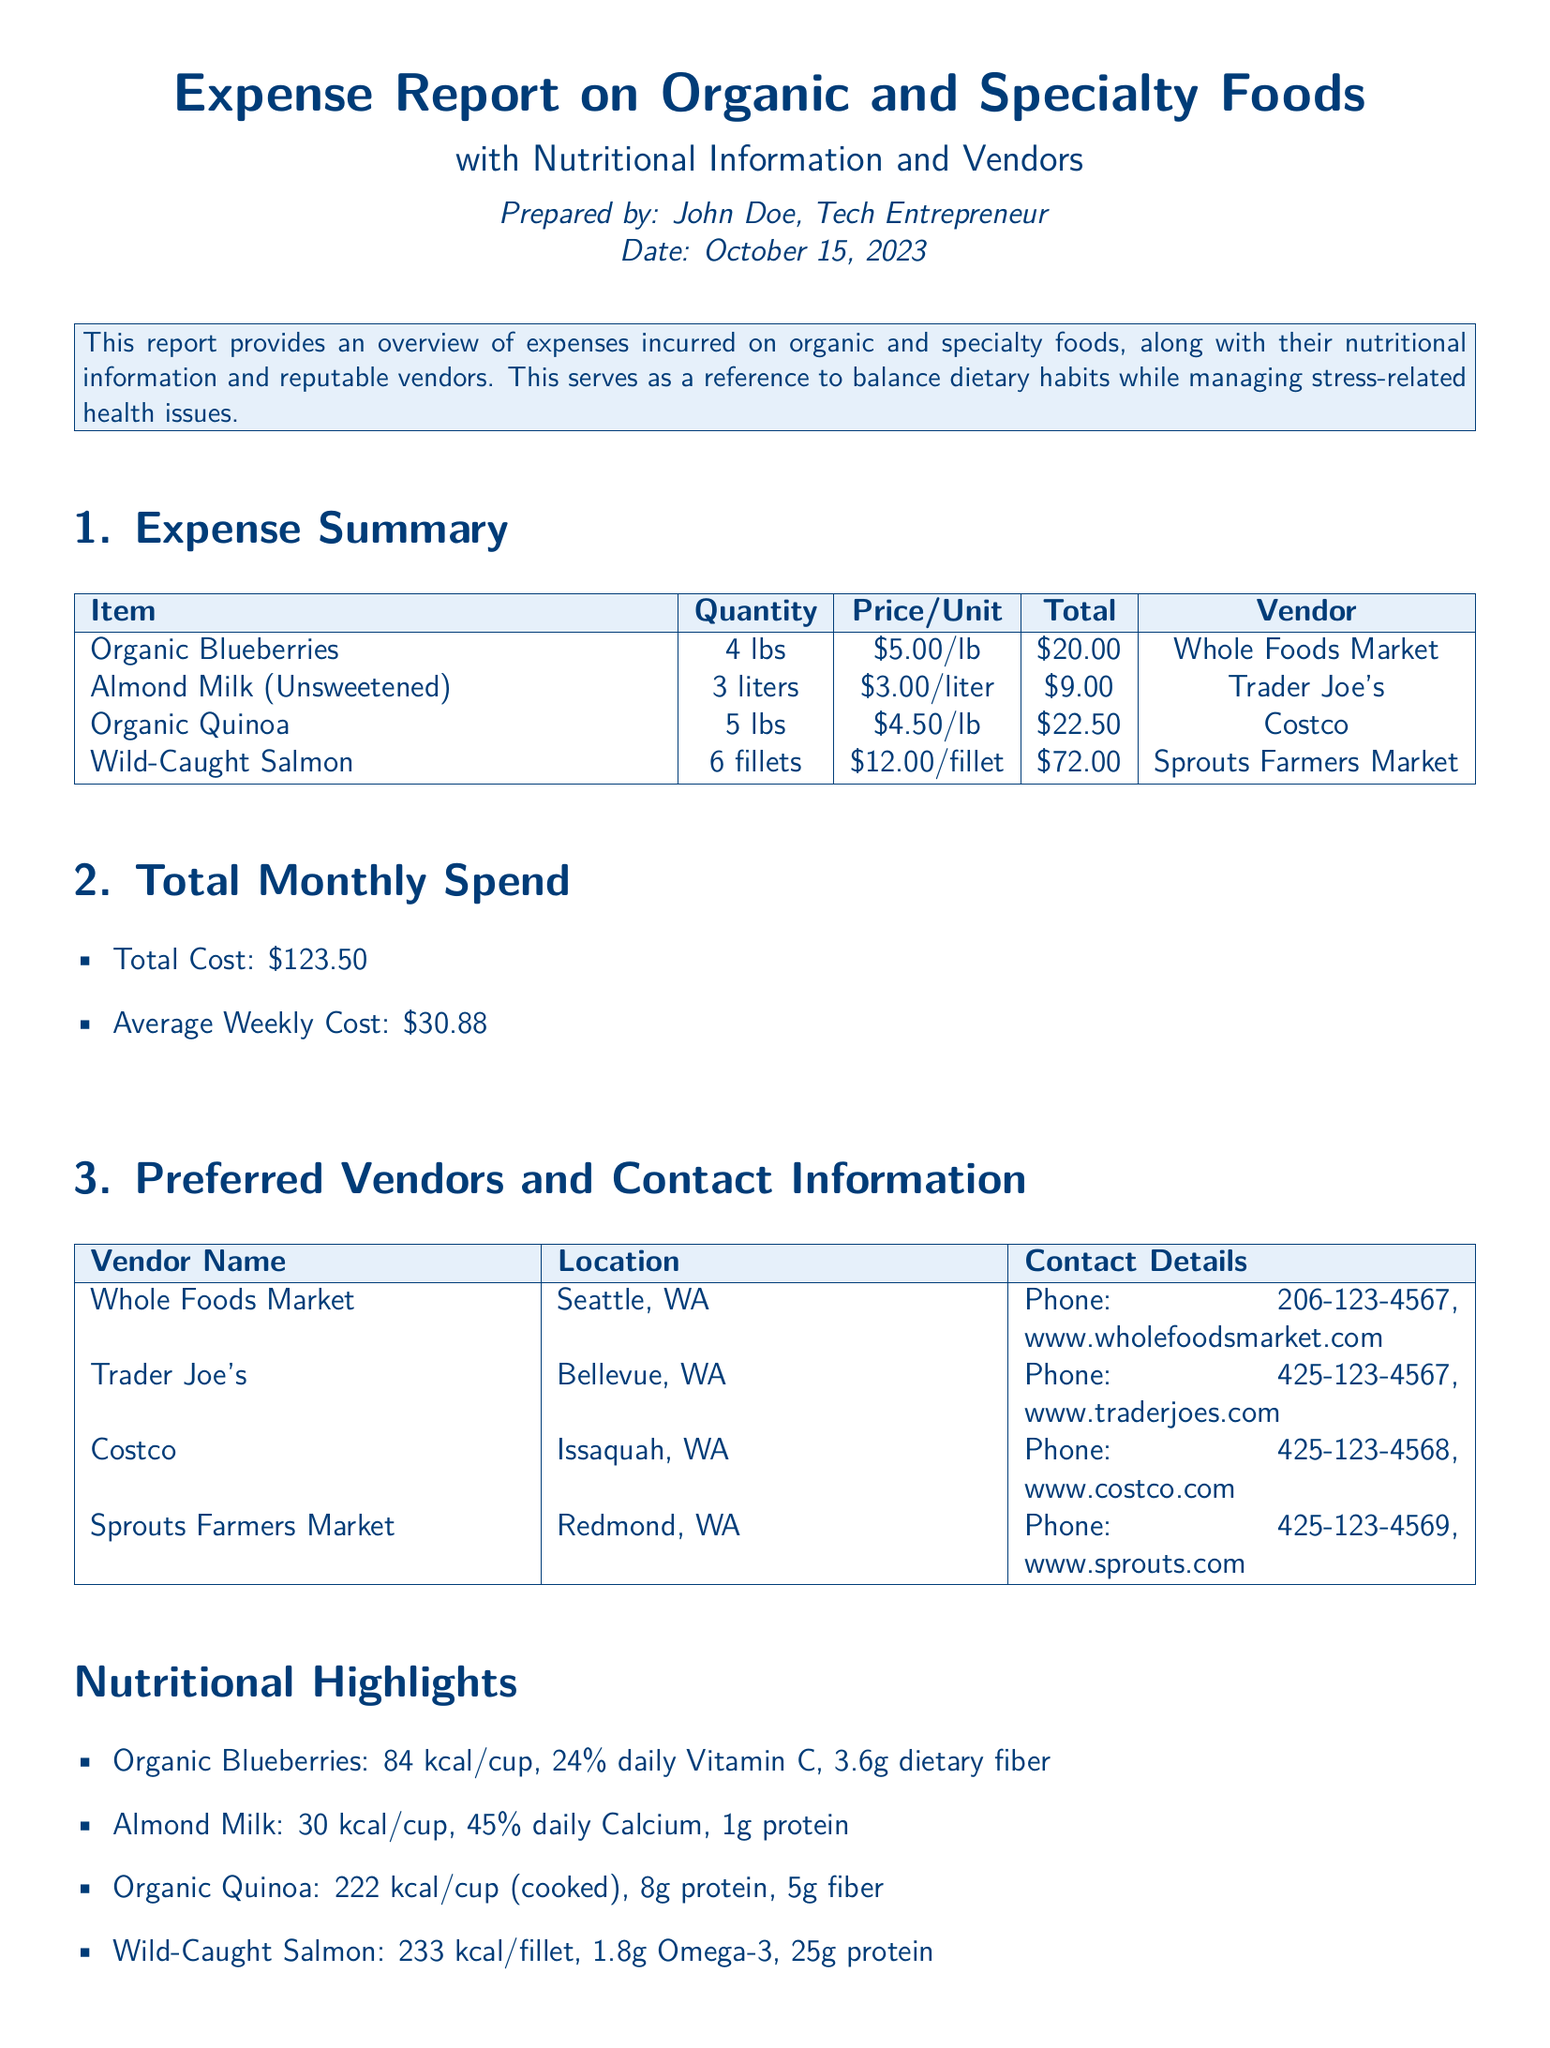What is the total cost of expenses? The total cost is shown in the Total Monthly Spend section as $123.50.
Answer: $123.50 How many pounds of organic blueberries were purchased? The Quantity column in the Expense Summary shows that 4 lbs of organic blueberries were purchased.
Answer: 4 lbs Who is the vendor for wild-caught salmon? The Expense Summary lists Sprouts Farmers Market as the vendor for wild-caught salmon.
Answer: Sprouts Farmers Market What is the average weekly cost of the expenses? The average weekly cost is calculated in the Total Monthly Spend section as $30.88.
Answer: $30.88 How many grams of protein are in one fillet of wild-caught salmon? The Nutritional Highlights indicate that one fillet contains 25g of protein.
Answer: 25g Which vendor is located in Bellevue, WA? The Preferred Vendors section states that Trader Joe's is located in Bellevue, WA.
Answer: Trader Joe's What is the daily Vitamin C percentage in organic blueberries? The Nutritional Highlights show that organic blueberries provide 24% daily Vitamin C.
Answer: 24% How much does a liter of almond milk cost? The Price/Unit for almond milk in the Expense Summary shows it costs $3.00/liter.
Answer: $3.00/liter What is the location of Costco? The Preferred Vendors section lists Issaquah, WA as the location of Costco.
Answer: Issaquah, WA 